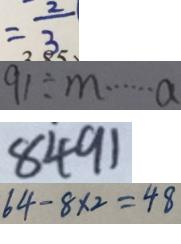<formula> <loc_0><loc_0><loc_500><loc_500>= \frac { 2 } { 3 } 
 9 1 \div m \cdots a 
 8 4 9 1 
 6 4 - 8 \times 2 = 4 8</formula> 